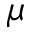<formula> <loc_0><loc_0><loc_500><loc_500>\mu</formula> 